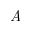<formula> <loc_0><loc_0><loc_500><loc_500>\emph { A }</formula> 